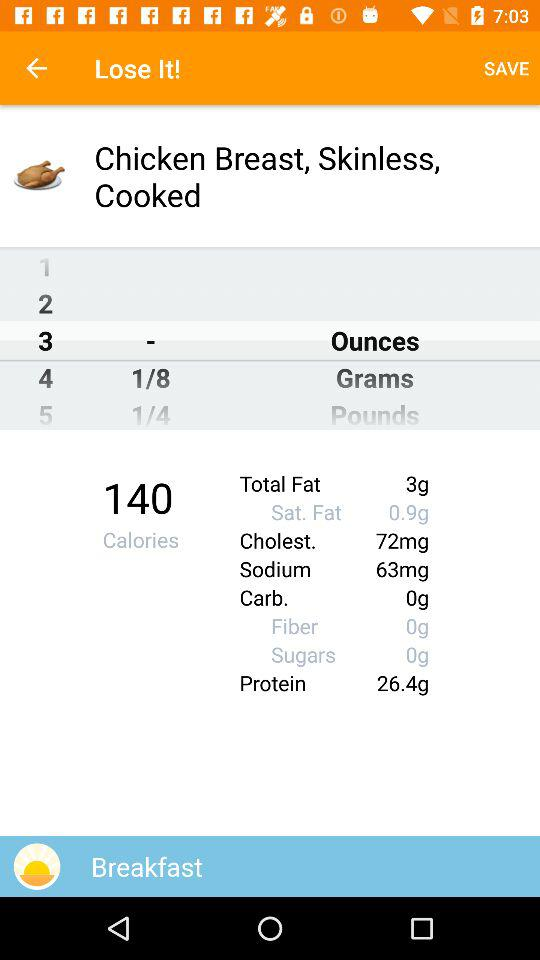How much fat is there in total? There are 3 grams of fat in total. 